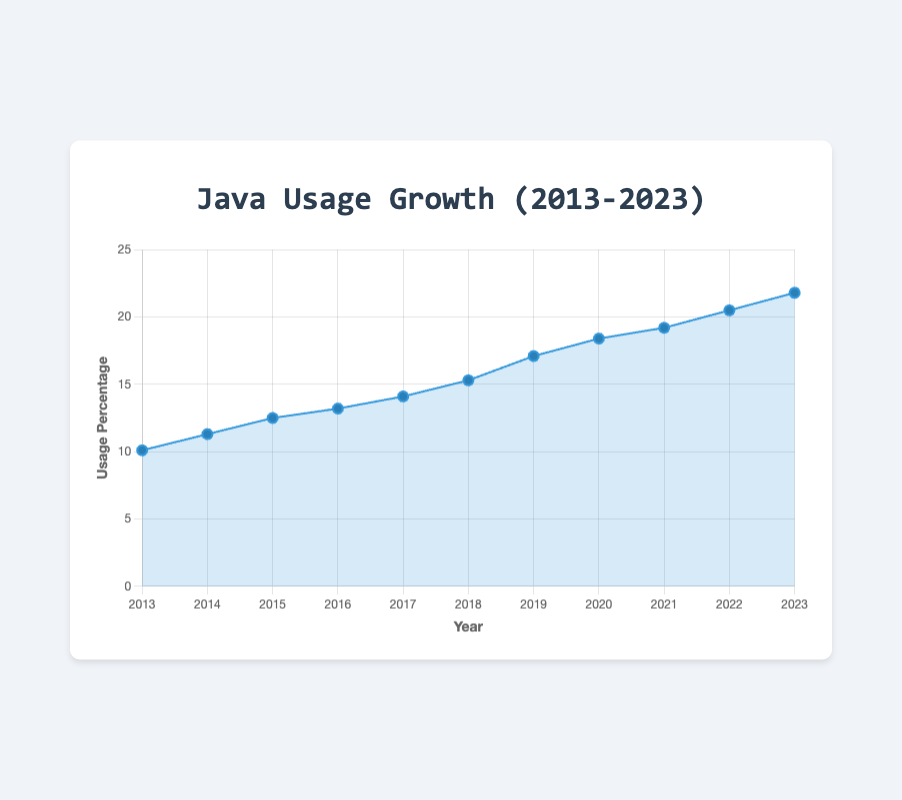Which year had the highest usage percentage for Java? By examining the figure, we see that the data point for 2023 is the highest at 21.8%.
Answer: 2023 What is the percentage increase in Java usage from 2013 to 2023? Subtract the percentage of 2013 from the percentage of 2023: 21.8% - 10.1% = 11.7%.
Answer: 11.7% What is the average Java usage percentage from 2013 to 2023? Add all the percentages from 2013 to 2023 and divide by the number of years. Sum = 10.1 + 11.3 + 12.5 + 13.2 + 14.1 + 15.3 + 17.1 + 18.4 + 19.2 + 20.5 + 21.8 = 173.5. Average = 173.5 / 11 ≈ 15.77.
Answer: 15.77% Which years saw a percentage increase greater than 1.0% from the previous year? Calculate the year-over-year percentage increase and identify those greater than 1.0%. For example, from 2013 to 2014: 11.3% - 10.1% = 1.2%, and so on. Identified years: 2014, 2015, 2018, 2019, 2022, 2023.
Answer: 2014, 2015, 2018, 2019, 2022, 2023 How many years did Java usage percentage increase consecutively? Observe the trend in the data points. Java usage increased consecutively from 2013 to 2023, which is 11 years.
Answer: 11 years Between which two consecutive years did the Java usage percentage increase the most? Calculate the increase for each consecutive year pair and compare. The largest increase is from 2018 to 2019: 17.1% - 15.3% = 1.8%.
Answer: 2018 to 2019 What was the Java usage percentage in 2015, and how does it compare to the percentage in 2010? The figure shows 12.5% in 2015. To understand the difference from 2010, we need the 2010 percentage, but since it is not provided, we can't compare.
Answer: 12.5% in 2015 What is the median Java usage percentage for the time period shown? Arrange the percentages in ascending order and find the middle value: (10.1, 11.3, 12.5, 13.2, 14.1, 15.3, 17.1, 18.4, 19.2, 20.5, 21.8). The middle value is 15.3%.
Answer: 15.3% In which year did Java usage percentage first exceed 15%? Check the graph for when the usage first surpasses 15%, which is in 2018 (15.3%).
Answer: 2018 